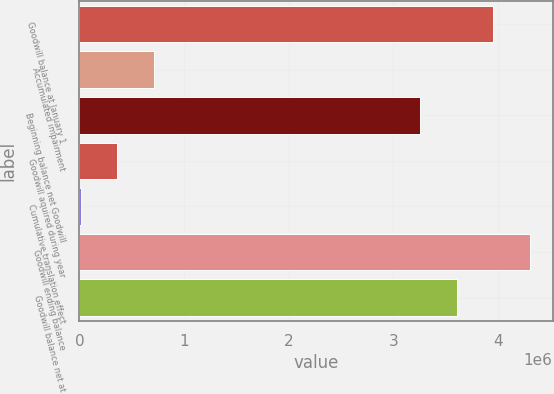<chart> <loc_0><loc_0><loc_500><loc_500><bar_chart><fcel>Goodwill balance at January 1<fcel>Accumulated impairment<fcel>Beginning balance net Goodwill<fcel>Goodwill aquired during year<fcel>Cumulative translation effect<fcel>Goodwill ending balance<fcel>Goodwill balance net at<nl><fcel>3.9552e+06<fcel>711389<fcel>3.25557e+06<fcel>361571<fcel>11752<fcel>4.30502e+06<fcel>3.60538e+06<nl></chart> 